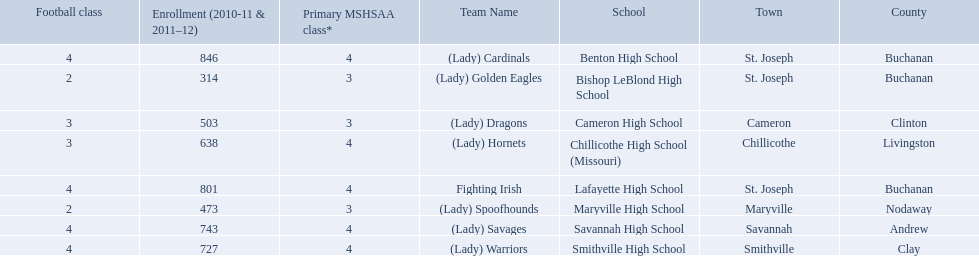What are the names of the schools? Benton High School, Bishop LeBlond High School, Cameron High School, Chillicothe High School (Missouri), Lafayette High School, Maryville High School, Savannah High School, Smithville High School. Of those, which had a total enrollment of less than 500? Bishop LeBlond High School, Maryville High School. And of those, which had the lowest enrollment? Bishop LeBlond High School. 